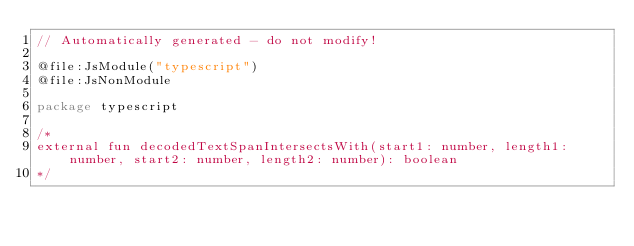Convert code to text. <code><loc_0><loc_0><loc_500><loc_500><_Kotlin_>// Automatically generated - do not modify!

@file:JsModule("typescript")
@file:JsNonModule

package typescript

/*
external fun decodedTextSpanIntersectsWith(start1: number, length1: number, start2: number, length2: number): boolean
*/
</code> 